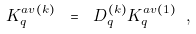<formula> <loc_0><loc_0><loc_500><loc_500>K ^ { a v ( k ) } _ { q } \ = \ D ^ { ( k ) } _ { q } K ^ { a v ( 1 ) } _ { q } \ ,</formula> 